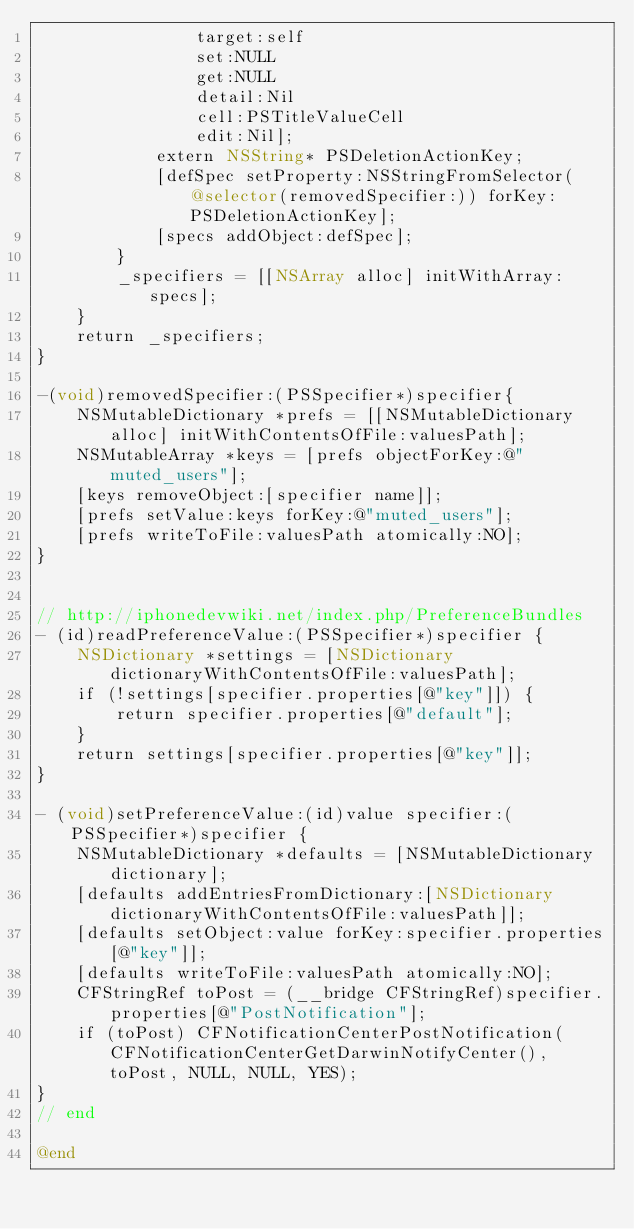Convert code to text. <code><loc_0><loc_0><loc_500><loc_500><_ObjectiveC_>				target:self
				set:NULL
				get:NULL
				detail:Nil
				cell:PSTitleValueCell
				edit:Nil];
			extern NSString* PSDeletionActionKey;
			[defSpec setProperty:NSStringFromSelector(@selector(removedSpecifier:)) forKey:PSDeletionActionKey];
			[specs addObject:defSpec];
		}
		_specifiers = [[NSArray alloc] initWithArray:specs];
	}
	return _specifiers;
}

-(void)removedSpecifier:(PSSpecifier*)specifier{
	NSMutableDictionary *prefs = [[NSMutableDictionary alloc] initWithContentsOfFile:valuesPath];
	NSMutableArray *keys = [prefs objectForKey:@"muted_users"];
	[keys removeObject:[specifier name]];
	[prefs setValue:keys forKey:@"muted_users"];
	[prefs writeToFile:valuesPath atomically:NO];
}


// http://iphonedevwiki.net/index.php/PreferenceBundles
- (id)readPreferenceValue:(PSSpecifier*)specifier {
	NSDictionary *settings = [NSDictionary dictionaryWithContentsOfFile:valuesPath];
	if (!settings[specifier.properties[@"key"]]) {
		return specifier.properties[@"default"];
	}
	return settings[specifier.properties[@"key"]];
}

- (void)setPreferenceValue:(id)value specifier:(PSSpecifier*)specifier {
	NSMutableDictionary *defaults = [NSMutableDictionary dictionary];
	[defaults addEntriesFromDictionary:[NSDictionary dictionaryWithContentsOfFile:valuesPath]];
	[defaults setObject:value forKey:specifier.properties[@"key"]];
	[defaults writeToFile:valuesPath atomically:NO];
	CFStringRef toPost = (__bridge CFStringRef)specifier.properties[@"PostNotification"];
	if (toPost) CFNotificationCenterPostNotification(CFNotificationCenterGetDarwinNotifyCenter(), toPost, NULL, NULL, YES);
}
// end

@end

</code> 